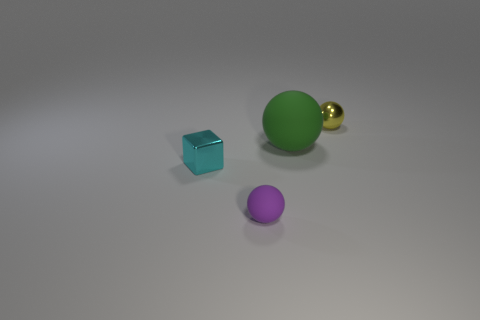Subtract all rubber spheres. How many spheres are left? 1 Subtract all purple balls. How many balls are left? 2 Add 3 metallic objects. How many objects exist? 7 Subtract all balls. How many objects are left? 1 Subtract all shiny cylinders. Subtract all matte balls. How many objects are left? 2 Add 1 small matte objects. How many small matte objects are left? 2 Add 1 green rubber balls. How many green rubber balls exist? 2 Subtract 0 brown cylinders. How many objects are left? 4 Subtract all red cubes. Subtract all yellow cylinders. How many cubes are left? 1 